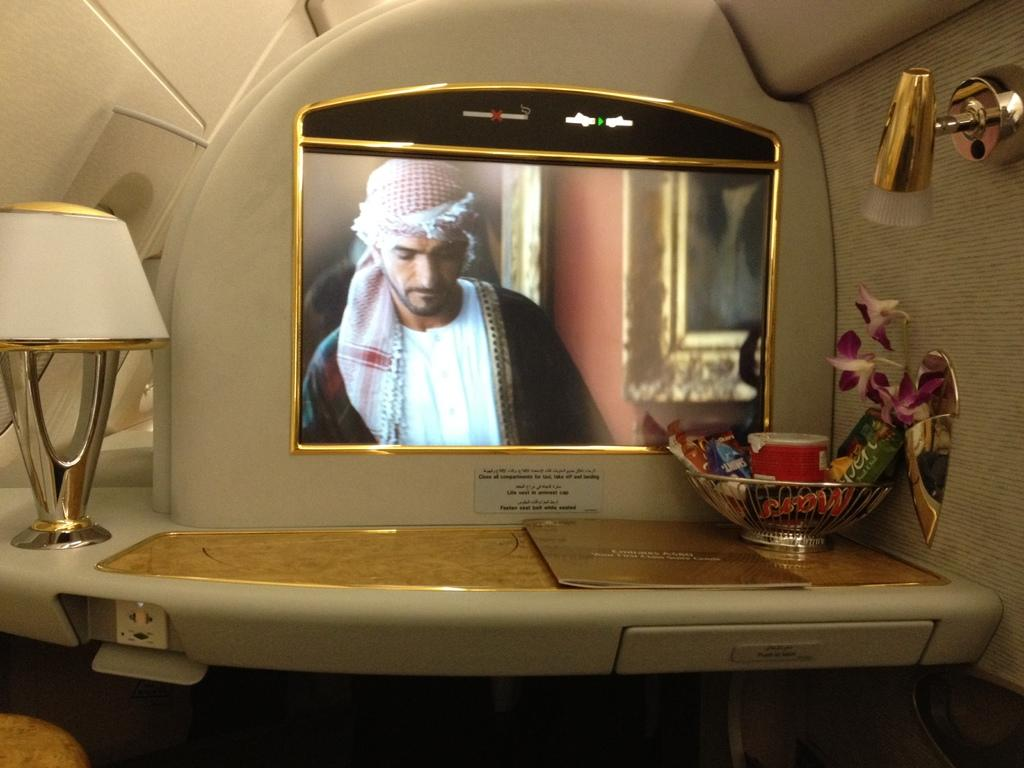What type of lighting fixture is present in the image? There is a lamp in the image. What is contained within the basket in the image? There are objects in a basket in the image. What type of natural decoration is present in the image? There are flowers in the image. What type of display device is present in the image? There is a screen in the image. Who or what is visible on the screen? A person is visible on the screen. What type of light source is present in the image? There is a light in the image. What type of stationery item is present in the image? There is a card in the image. What type of statement is written on the card in the image? There is no statement written on the card in the image; it is just a card. What type of head is visible on the screen in the image? There is no head visible on the screen in the image; a person is visible, but not just their head. 